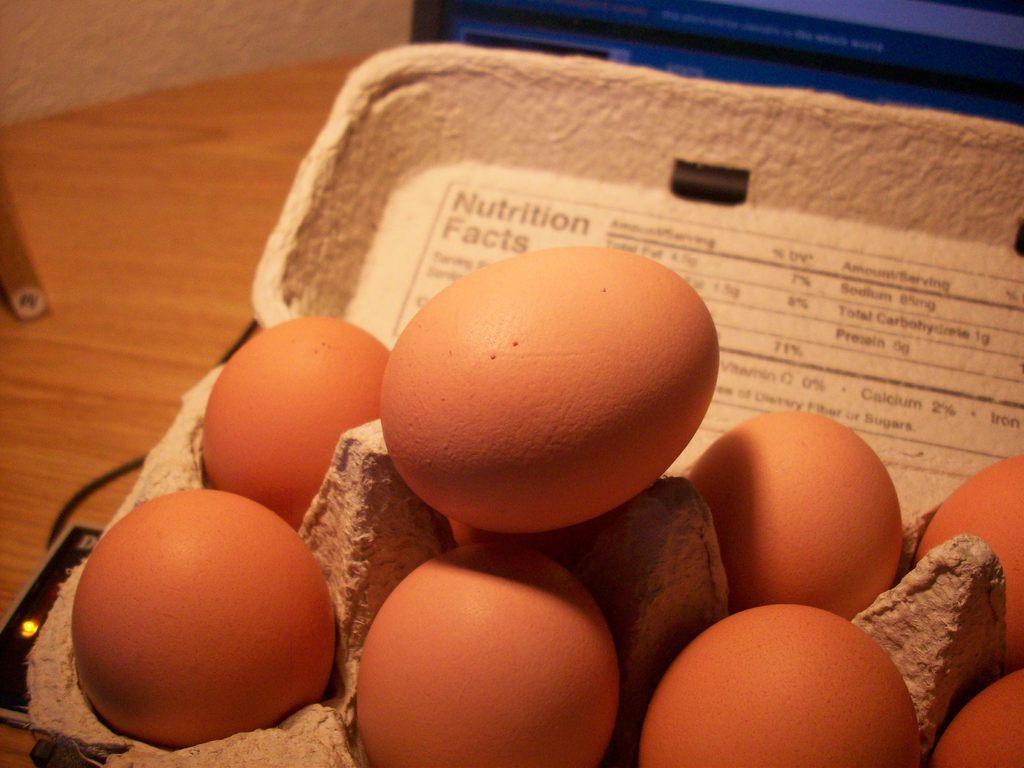Could you give a brief overview of what you see in this image? In this picture there is a tray of eggs in the image and there is a wire on the left side of the image. 